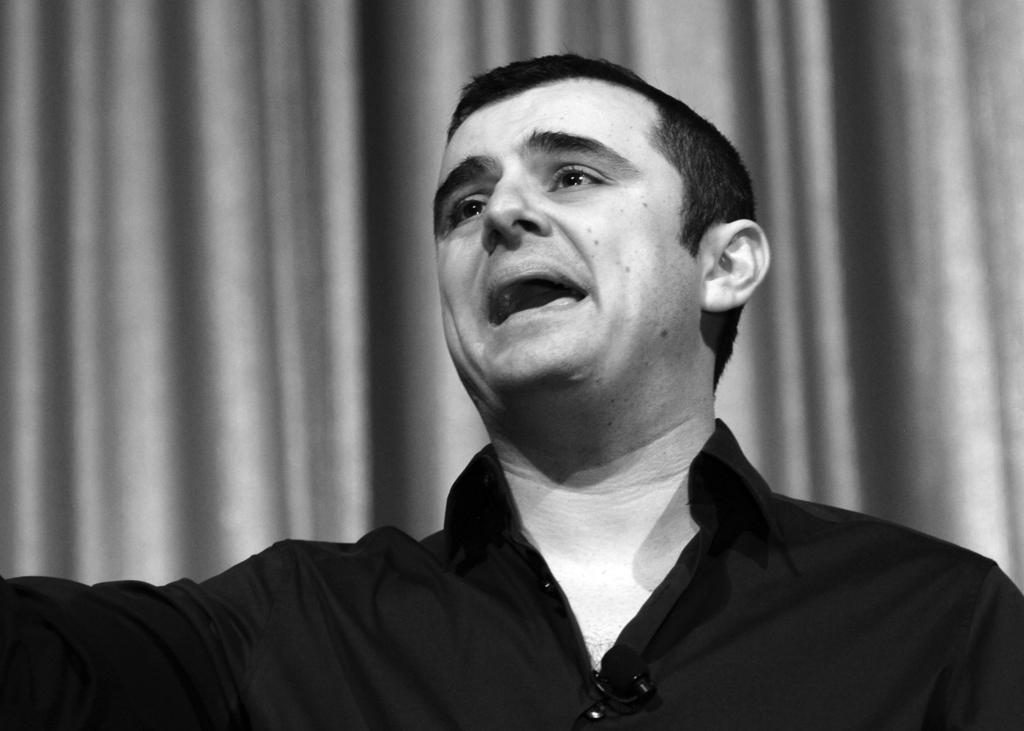What is the person in the image wearing? The person is wearing a black shirt in the image. What is the person doing in the image? The person is speaking in the image. How does the person appear to be feeling in the image? The person appears to be in a bad mood in the image. What can be seen in the background of the image? There is a curtain in the background of the image. What type of crush is the person experiencing in the image? There is no indication of a crush in the image; it only shows a person wearing a black shirt, speaking, and appearing to be in a bad mood. 